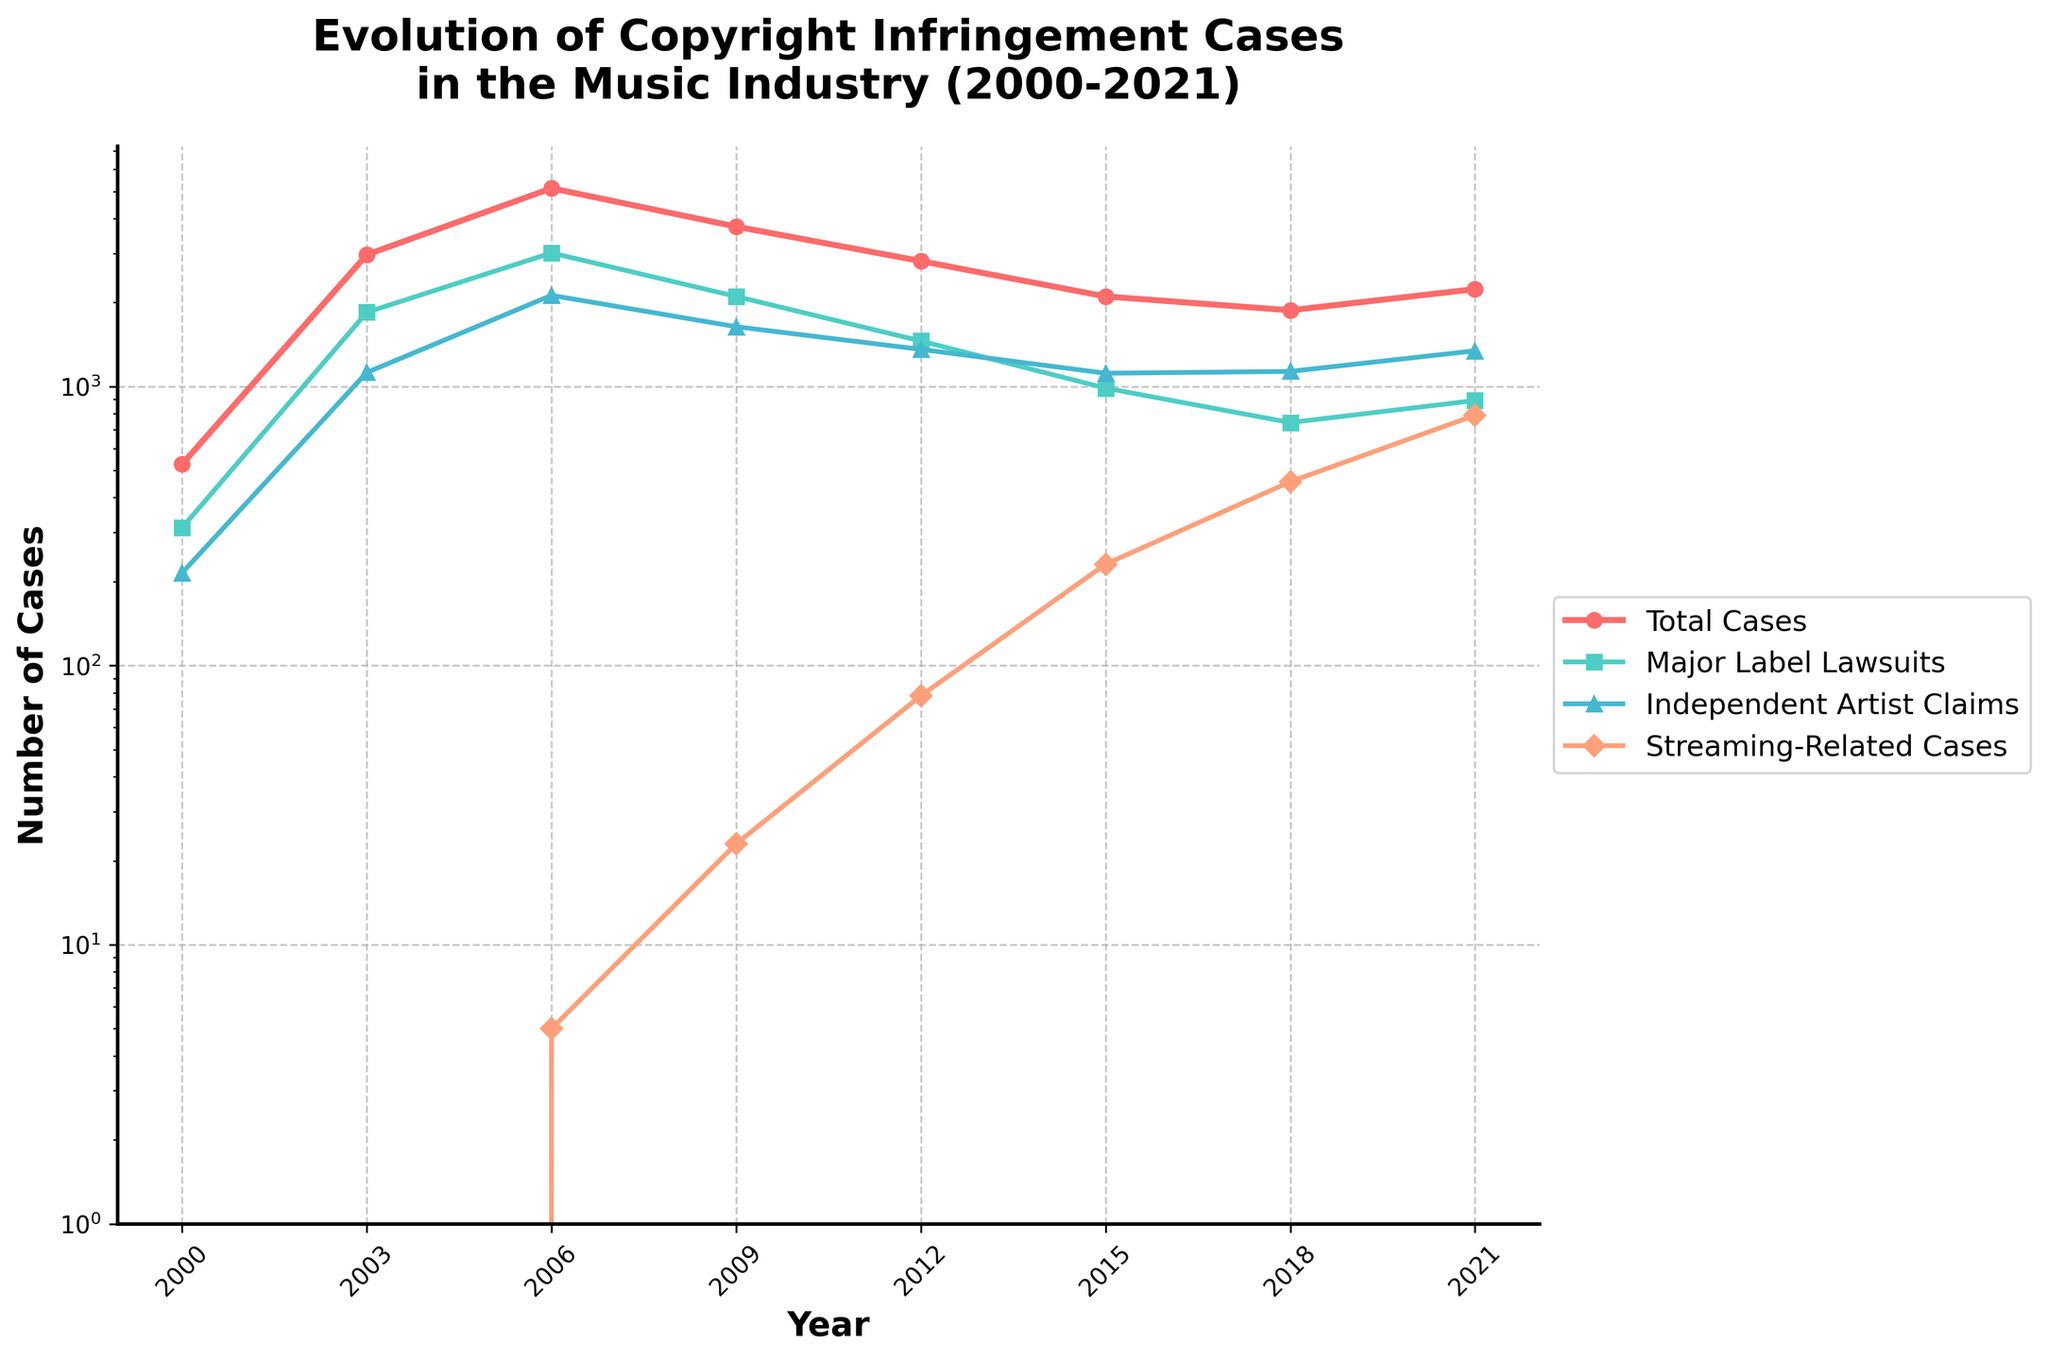Which year saw the highest number of major label lawsuits? Look at the line representing Major Label Lawsuits and find the highest point. The peak is in 2006.
Answer: 2006 Between 2003 and 2009, how much did the number of total copyright infringement cases decrease? In 2003, the number of cases was 2968. In 2009, it was 3741. The decrease is 2968 - 3741 = -773. Since it is negative, it means it actually increased by 773.
Answer: 773 increase How many more independent artist claims were there in 2006 compared to 2000? The number of independent artist claims in 2006 was 2122, and in 2000 it was 215. The difference is 2122 - 215 = 1907.
Answer: 1907 more Looking at the trends, in which year did streaming-related cases start, and what was their count? Streaming-related cases started in 2006, with the first count being 5.
Answer: 2006, 5 What is the total number of copyright infringement cases in 2018 and 2021 combined? In 2018, there were 1876 cases, and in 2021, there were 2234 cases. The total is 1876 + 2234 = 4110.
Answer: 4110 Which category has a consistent downward trend from 2006 to 2018? Look at each line for the entire period. Both Total Cases and Major Label Lawsuits show a consistent downward trend, but Major Label Lawsuits is the one that is significant and consistent.
Answer: Major Label Lawsuits How many total copyright infringement cases were there across all years from 2000 to 2021? Sum the number of cases for each year: 527 + 2968 + 5134 + 3741 + 2815 + 2103 + 1876 + 2234 = 21398.
Answer: 21398 In which year did independent artist claims exceed 1000 for the first time? Find the year where the line representing Independent Artist Claims first crosses the 1000 mark. It is in 2003.
Answer: 2003 What was the approximate percentage increase in RIAA settlements from 2000 to 2006? The settlements in 2000 were 50.2 million, and in 2006 they were 232.7 million. The percentage increase is ((232.7 - 50.2) / 50.2) * 100 ≈ 363.2%.
Answer: 363.2% Compare the number of total copyright infringement cases in 2000 and the number of streaming-related cases in 2021. Which one is greater? There were 527 total cases in 2000 and 789 streaming-related cases in 2021. 789 is greater than 527.
Answer: Streaming-related cases in 2021 